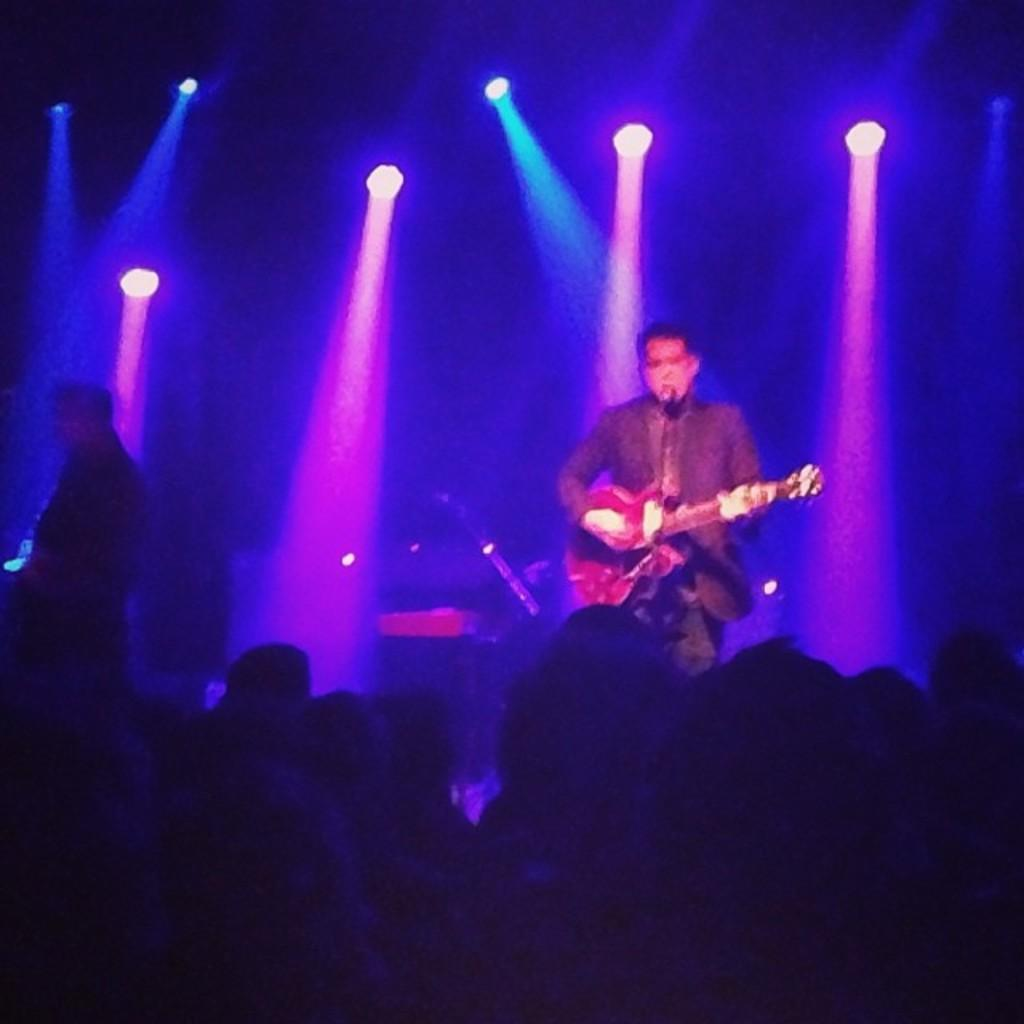What is happening in the image involving the group of people? In the image, a man is playing a guitar in front of a microphone, and there is a group of people present. What instrument is the man playing? The man is playing a guitar in the image. Where is the man positioned in relation to the microphone? The man is in front of a microphone in the image. What can be seen in the background of the image? There are lights visible in the background of the image. What type of doll is sitting on the bag in the image? There is no doll or bag present in the image. How does the man's voice sound while playing the guitar in the image? The image does not provide any information about the man's voice or how it sounds. 